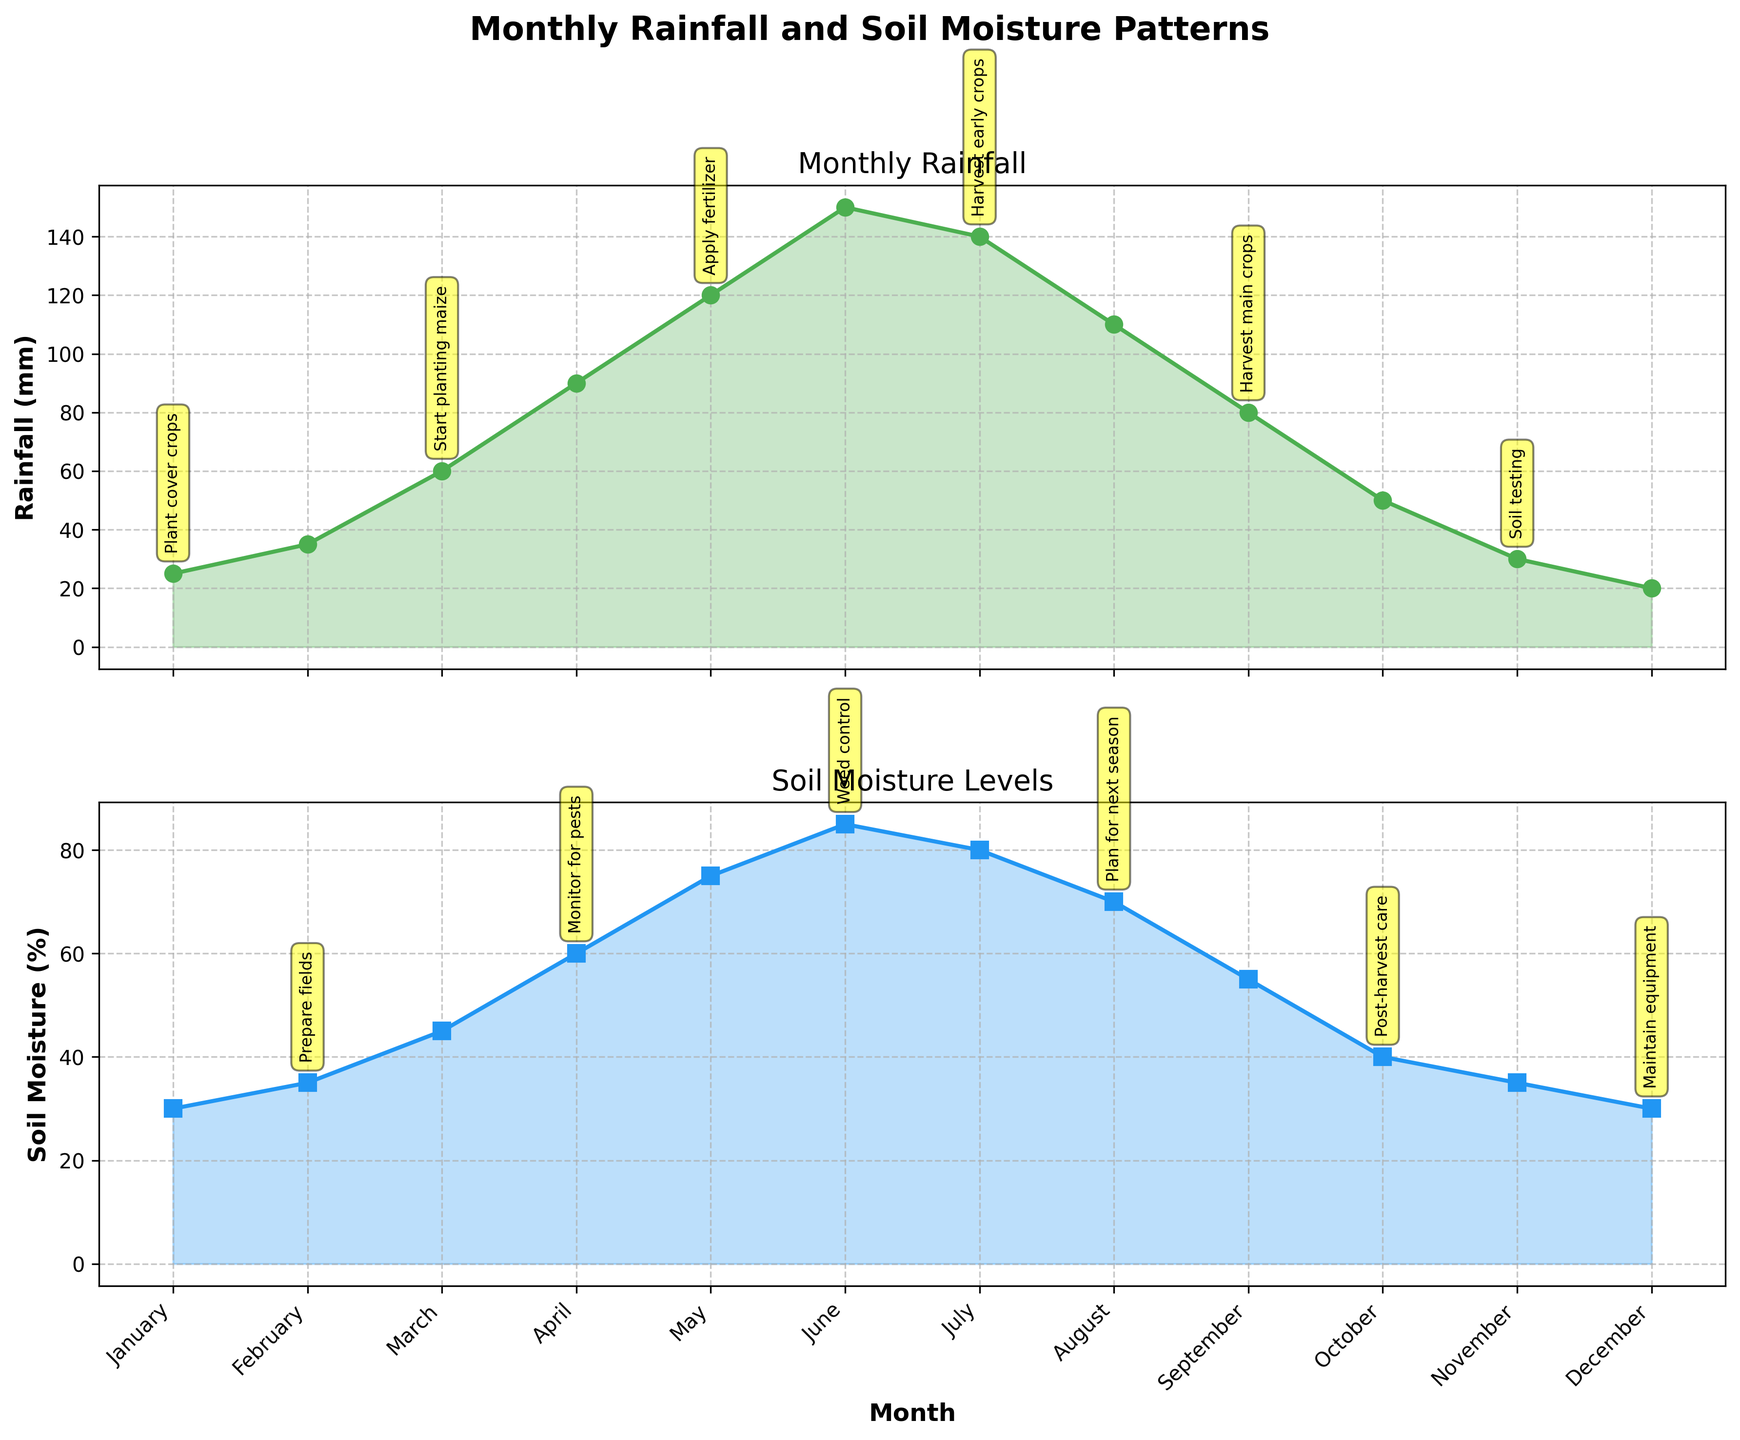which month has the highest rainfall? To find the month with the highest rainfall, look at the rainfall plot and identify the peak point. The rainfall reaches its highest value in June.
Answer: June how does soil moisture change from January to December? To track soil moisture change from January to December, follow the soil moisture plot line from the start to the end. Soil moisture starts at 30% in January, increases to a peak in June at 85%, then gradually decreases to 30% in December.
Answer: Increases then decreases compare rainfall in July and August Look at the rainfall data points for July and August in the rainfall plot. Rainfall is 140 mm in July and 110 mm in August. Thus, July has more rainfall than August.
Answer: July has more what is the relationship between rainfall and the chief's advice in May? Look at the chief's advice annotation in May below the rainfall plot. It advises to apply fertilizer, which aligns with high rainfall (120 mm), aiding nutrient absorption by crops.
Answer: Apply fertilizer what is the difference in soil moisture between April and May? Find soil moisture values for April (60%) and May (75%) on the soil moisture plot. Subtract April's moisture from May's: 75% - 60% = 15%.
Answer: 15% is there a trend between rainfall and soil moisture levels? Observe both plots; generally, as rainfall increases, soil moisture levels also increase. For instance, from January to June, both rainfall and soil moisture rise, and similarly, both decrease from June to December.
Answer: Yes, a positive correlation which month shows the most significant drop in rainfall compared to the previous month? Identify the steepest downward slope in the rainfall plot. From June (150 mm) to July (140 mm), there is a drop of 10 mm, but from October (50 mm) to November (30 mm), it drops by 20 mm. Thus, the most significant drop occurs from October to November.
Answer: October to November what advice is given by the chief in September, and how does it relate to rainfall and soil moisture? Check the chief's advice annotation in September under the soil moisture plot. The advice is to harvest main crops, which is sensible since both rainfall (80 mm) and soil moisture (55%) are starting to decline, indicating approaching drier conditions.
Answer: Harvest main crops compare the yearly maximums for rainfall and soil moisture. Check the peaks in both plots. Rainfall peaks at 150 mm in June, while soil moisture peaks at 85% in June.
Answer: Both peak in June 